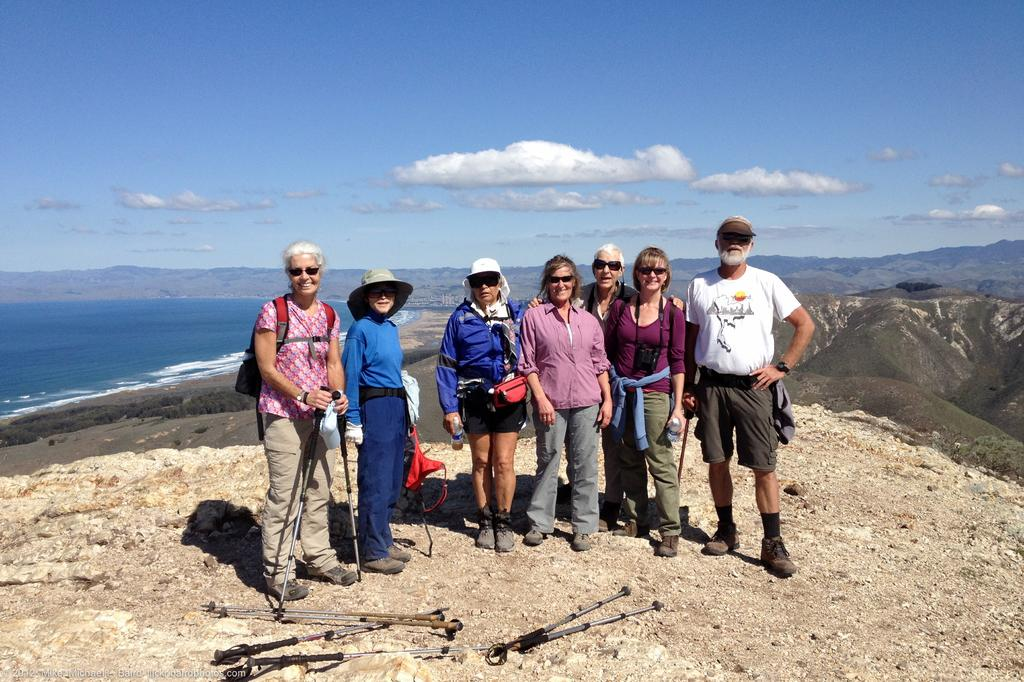What are the people in the image doing? The people in the image are standing. What are the people wearing on their faces? The people are wearing goggles. What is one person carrying in the image? One person is wearing a bag. What is the person with the bag holding? The person with the bag is holding a stand. What can be seen in the background of the image? Water, hills, and the sky are visible in the background of the image. What is the condition of the sky in the image? The sky is visible with clouds in the background of the image. What type of instrument does the person with the fang play in the image? There is no person with a fang or any musical instruments present in the image. 